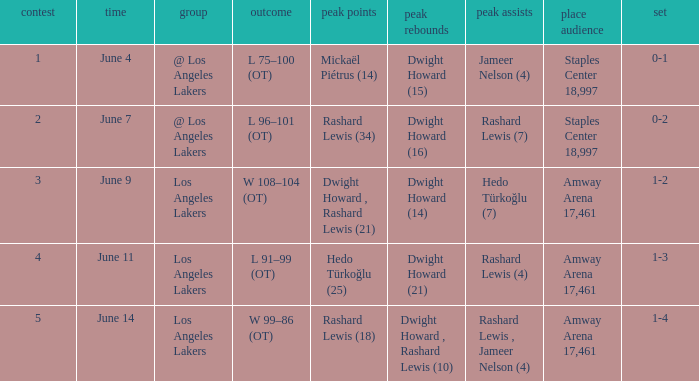What is Team, when High Assists is "Rashard Lewis (4)"? Los Angeles Lakers. 